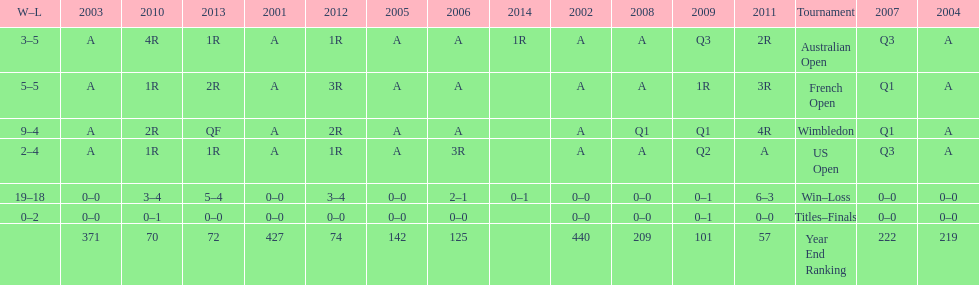What is the difference in wins between wimbledon and the us open for this player? 7. 